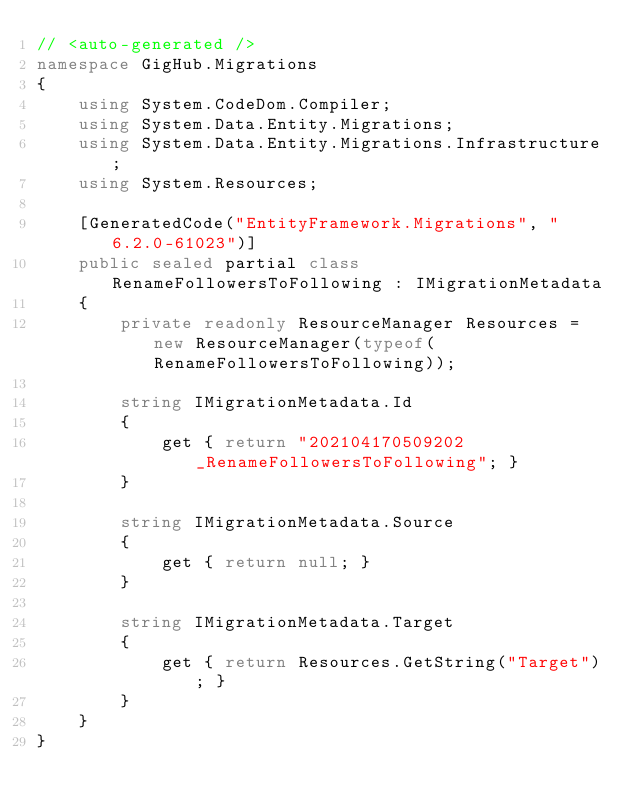Convert code to text. <code><loc_0><loc_0><loc_500><loc_500><_C#_>// <auto-generated />
namespace GigHub.Migrations
{
    using System.CodeDom.Compiler;
    using System.Data.Entity.Migrations;
    using System.Data.Entity.Migrations.Infrastructure;
    using System.Resources;
    
    [GeneratedCode("EntityFramework.Migrations", "6.2.0-61023")]
    public sealed partial class RenameFollowersToFollowing : IMigrationMetadata
    {
        private readonly ResourceManager Resources = new ResourceManager(typeof(RenameFollowersToFollowing));
        
        string IMigrationMetadata.Id
        {
            get { return "202104170509202_RenameFollowersToFollowing"; }
        }
        
        string IMigrationMetadata.Source
        {
            get { return null; }
        }
        
        string IMigrationMetadata.Target
        {
            get { return Resources.GetString("Target"); }
        }
    }
}
</code> 